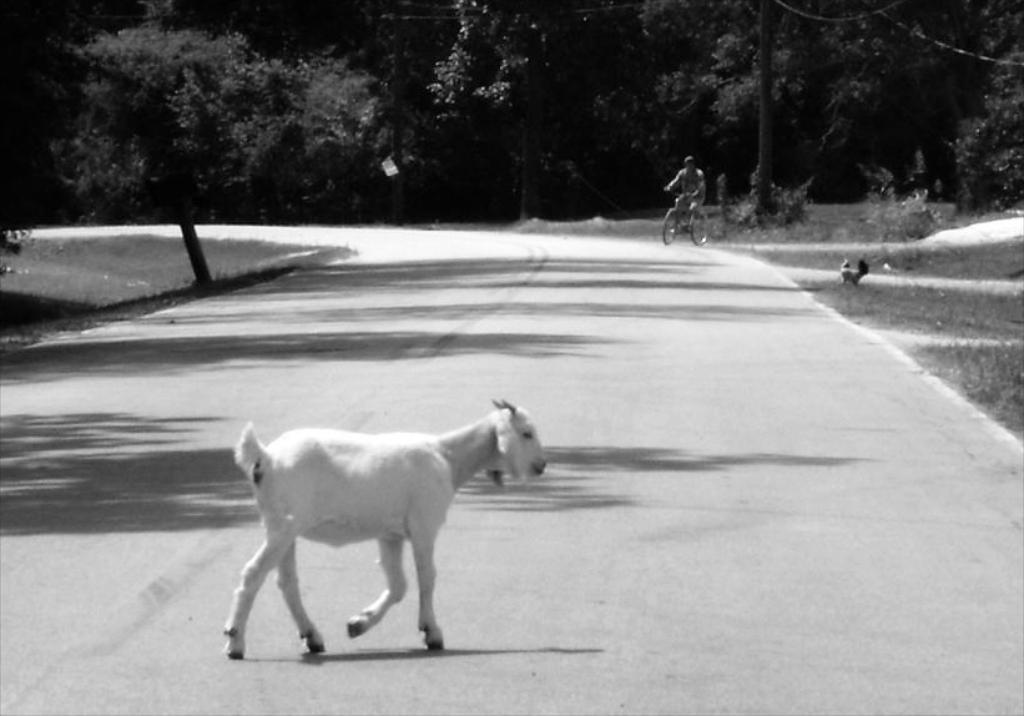Can you describe this image briefly? This is a black and white image. Here I can see a goat is walking on the road towards the right side. In the background there is a man riding the bicycle. On both sides of the road I can see the grass. On the right side there is a hen. In the background there are many trees. 